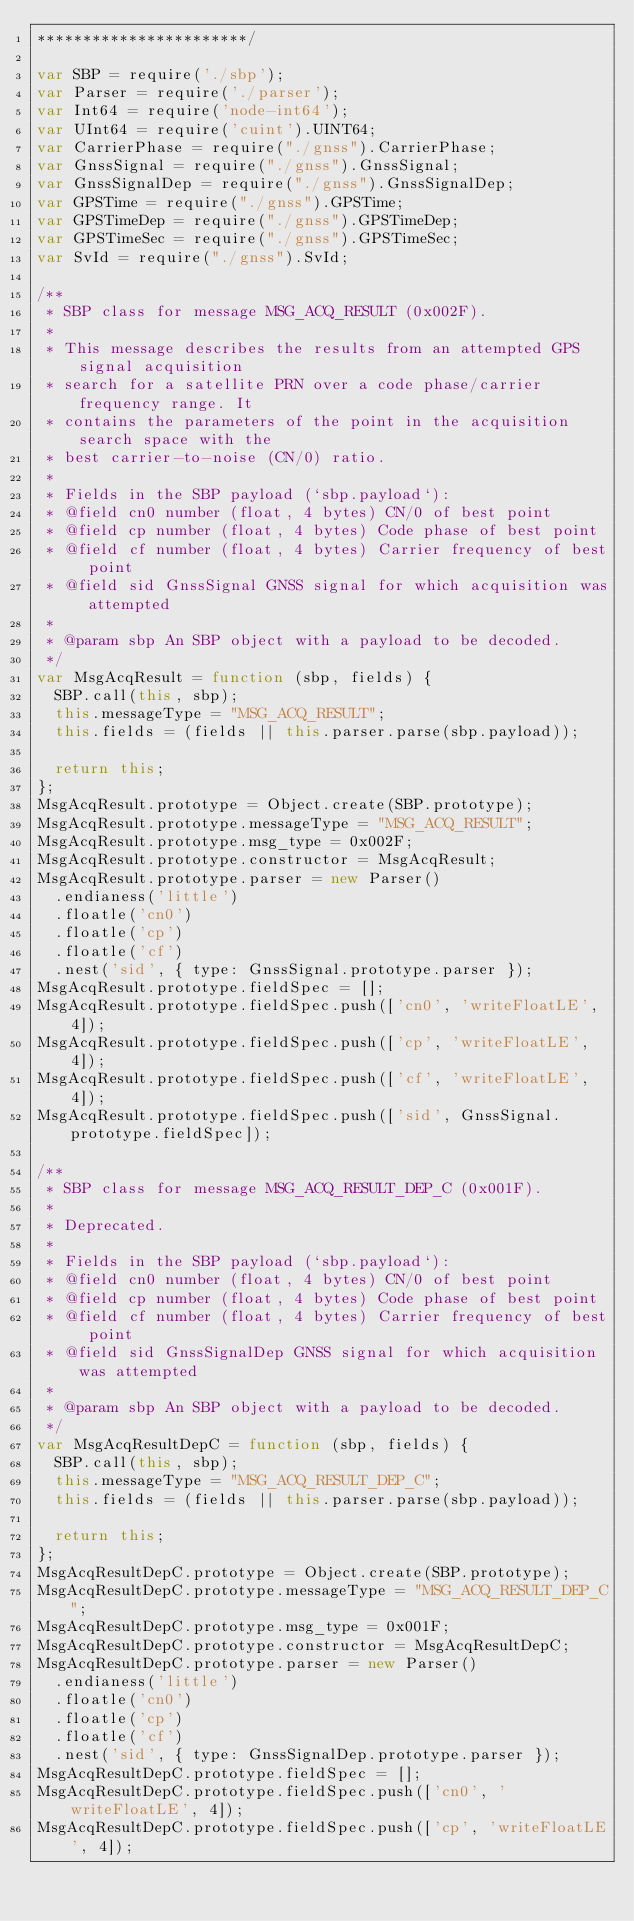<code> <loc_0><loc_0><loc_500><loc_500><_JavaScript_>***********************/

var SBP = require('./sbp');
var Parser = require('./parser');
var Int64 = require('node-int64');
var UInt64 = require('cuint').UINT64;
var CarrierPhase = require("./gnss").CarrierPhase;
var GnssSignal = require("./gnss").GnssSignal;
var GnssSignalDep = require("./gnss").GnssSignalDep;
var GPSTime = require("./gnss").GPSTime;
var GPSTimeDep = require("./gnss").GPSTimeDep;
var GPSTimeSec = require("./gnss").GPSTimeSec;
var SvId = require("./gnss").SvId;

/**
 * SBP class for message MSG_ACQ_RESULT (0x002F).
 *
 * This message describes the results from an attempted GPS signal acquisition
 * search for a satellite PRN over a code phase/carrier frequency range. It
 * contains the parameters of the point in the acquisition search space with the
 * best carrier-to-noise (CN/0) ratio.
 *
 * Fields in the SBP payload (`sbp.payload`):
 * @field cn0 number (float, 4 bytes) CN/0 of best point
 * @field cp number (float, 4 bytes) Code phase of best point
 * @field cf number (float, 4 bytes) Carrier frequency of best point
 * @field sid GnssSignal GNSS signal for which acquisition was attempted
 *
 * @param sbp An SBP object with a payload to be decoded.
 */
var MsgAcqResult = function (sbp, fields) {
  SBP.call(this, sbp);
  this.messageType = "MSG_ACQ_RESULT";
  this.fields = (fields || this.parser.parse(sbp.payload));

  return this;
};
MsgAcqResult.prototype = Object.create(SBP.prototype);
MsgAcqResult.prototype.messageType = "MSG_ACQ_RESULT";
MsgAcqResult.prototype.msg_type = 0x002F;
MsgAcqResult.prototype.constructor = MsgAcqResult;
MsgAcqResult.prototype.parser = new Parser()
  .endianess('little')
  .floatle('cn0')
  .floatle('cp')
  .floatle('cf')
  .nest('sid', { type: GnssSignal.prototype.parser });
MsgAcqResult.prototype.fieldSpec = [];
MsgAcqResult.prototype.fieldSpec.push(['cn0', 'writeFloatLE', 4]);
MsgAcqResult.prototype.fieldSpec.push(['cp', 'writeFloatLE', 4]);
MsgAcqResult.prototype.fieldSpec.push(['cf', 'writeFloatLE', 4]);
MsgAcqResult.prototype.fieldSpec.push(['sid', GnssSignal.prototype.fieldSpec]);

/**
 * SBP class for message MSG_ACQ_RESULT_DEP_C (0x001F).
 *
 * Deprecated.
 *
 * Fields in the SBP payload (`sbp.payload`):
 * @field cn0 number (float, 4 bytes) CN/0 of best point
 * @field cp number (float, 4 bytes) Code phase of best point
 * @field cf number (float, 4 bytes) Carrier frequency of best point
 * @field sid GnssSignalDep GNSS signal for which acquisition was attempted
 *
 * @param sbp An SBP object with a payload to be decoded.
 */
var MsgAcqResultDepC = function (sbp, fields) {
  SBP.call(this, sbp);
  this.messageType = "MSG_ACQ_RESULT_DEP_C";
  this.fields = (fields || this.parser.parse(sbp.payload));

  return this;
};
MsgAcqResultDepC.prototype = Object.create(SBP.prototype);
MsgAcqResultDepC.prototype.messageType = "MSG_ACQ_RESULT_DEP_C";
MsgAcqResultDepC.prototype.msg_type = 0x001F;
MsgAcqResultDepC.prototype.constructor = MsgAcqResultDepC;
MsgAcqResultDepC.prototype.parser = new Parser()
  .endianess('little')
  .floatle('cn0')
  .floatle('cp')
  .floatle('cf')
  .nest('sid', { type: GnssSignalDep.prototype.parser });
MsgAcqResultDepC.prototype.fieldSpec = [];
MsgAcqResultDepC.prototype.fieldSpec.push(['cn0', 'writeFloatLE', 4]);
MsgAcqResultDepC.prototype.fieldSpec.push(['cp', 'writeFloatLE', 4]);</code> 